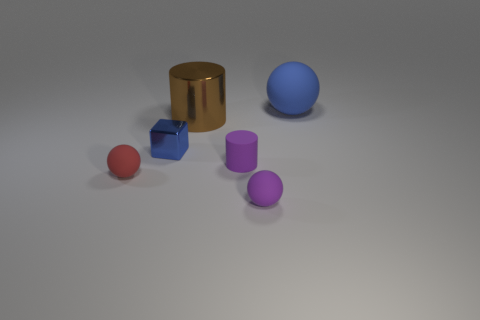How many other things are the same material as the red ball?
Provide a succinct answer. 3. Does the ball behind the tiny purple cylinder have the same size as the shiny thing that is on the left side of the large brown shiny object?
Provide a succinct answer. No. What number of objects are spheres that are behind the big metallic thing or metal objects right of the small shiny thing?
Your answer should be compact. 2. Is there any other thing that is the same shape as the red rubber object?
Provide a short and direct response. Yes. Is the color of the cylinder in front of the block the same as the large object in front of the big matte object?
Provide a succinct answer. No. What number of matte things are either things or small yellow cylinders?
Your answer should be very brief. 4. Is there any other thing that has the same size as the metallic cube?
Your response must be concise. Yes. What shape is the blue object on the left side of the matte sphere that is behind the red object?
Make the answer very short. Cube. Does the blue object that is in front of the blue matte object have the same material as the tiny object that is in front of the tiny red object?
Provide a short and direct response. No. There is a tiny sphere that is left of the purple rubber ball; how many matte things are behind it?
Your answer should be very brief. 2. 